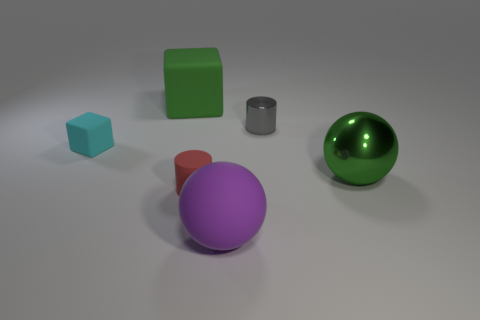What is the arrangement of objects in terms of relative positions to each other? The objects are spaced out across the surface in no particular pattern. The green cube is near the center, slightly to the left from the viewpoint, with the small blue cube to its right and slightly in front. The matte red cylinder and the grey cylinder are to the right of the green cube, positioned close to each other. In the background to the right, there is a large green sphere. Lastly, in the foreground and near the center, there is a prominent purple sphere. 